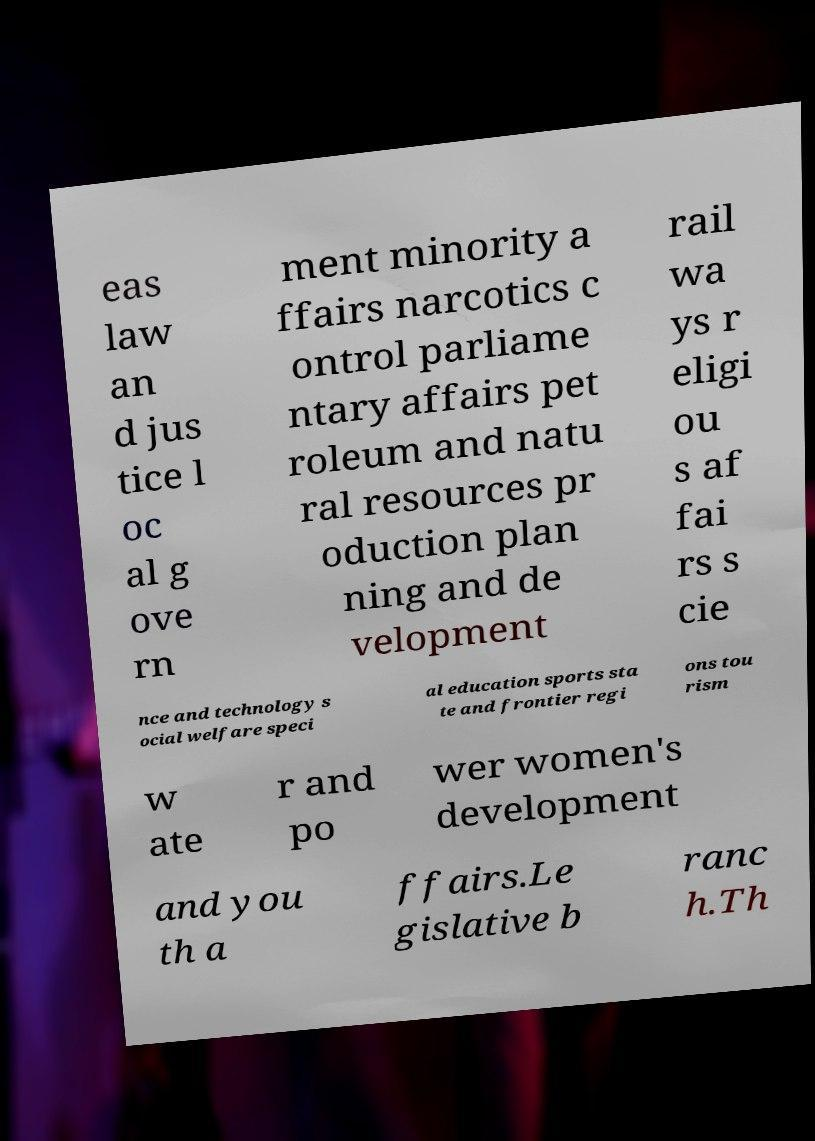Can you read and provide the text displayed in the image?This photo seems to have some interesting text. Can you extract and type it out for me? eas law an d jus tice l oc al g ove rn ment minority a ffairs narcotics c ontrol parliame ntary affairs pet roleum and natu ral resources pr oduction plan ning and de velopment rail wa ys r eligi ou s af fai rs s cie nce and technology s ocial welfare speci al education sports sta te and frontier regi ons tou rism w ate r and po wer women's development and you th a ffairs.Le gislative b ranc h.Th 